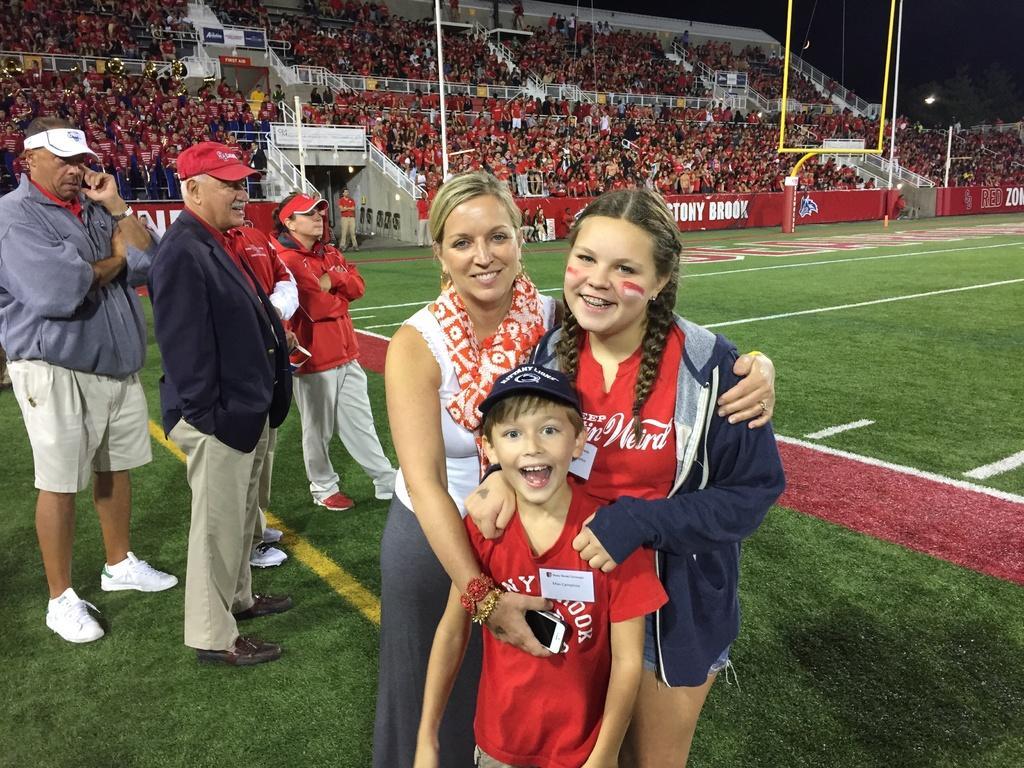Could you give a brief overview of what you see in this image? In this image I can see two women standing and a boy wearing red t shirt and blue hat is standing in front of them. In the background I can see few persons standing on the ground, the stadium, number of persons in the stadium, a light, a tree and the dark sky. 